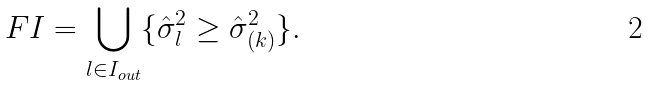<formula> <loc_0><loc_0><loc_500><loc_500>F I = \bigcup _ { l \in I _ { o u t } } \{ \hat { \sigma } _ { l } ^ { 2 } \geq \hat { \sigma } _ { ( k ) } ^ { 2 } \} .</formula> 